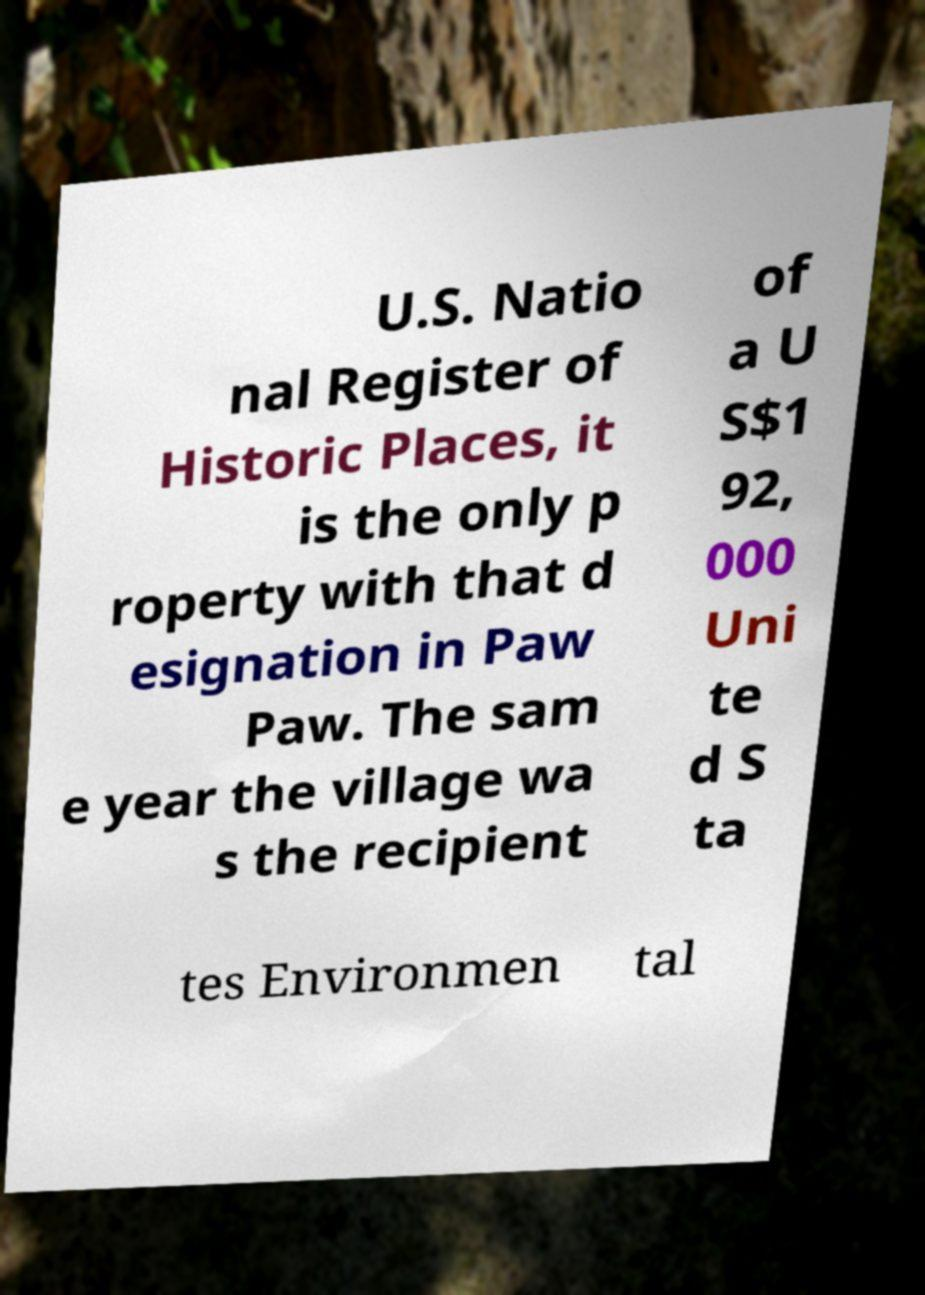Please identify and transcribe the text found in this image. U.S. Natio nal Register of Historic Places, it is the only p roperty with that d esignation in Paw Paw. The sam e year the village wa s the recipient of a U S$1 92, 000 Uni te d S ta tes Environmen tal 